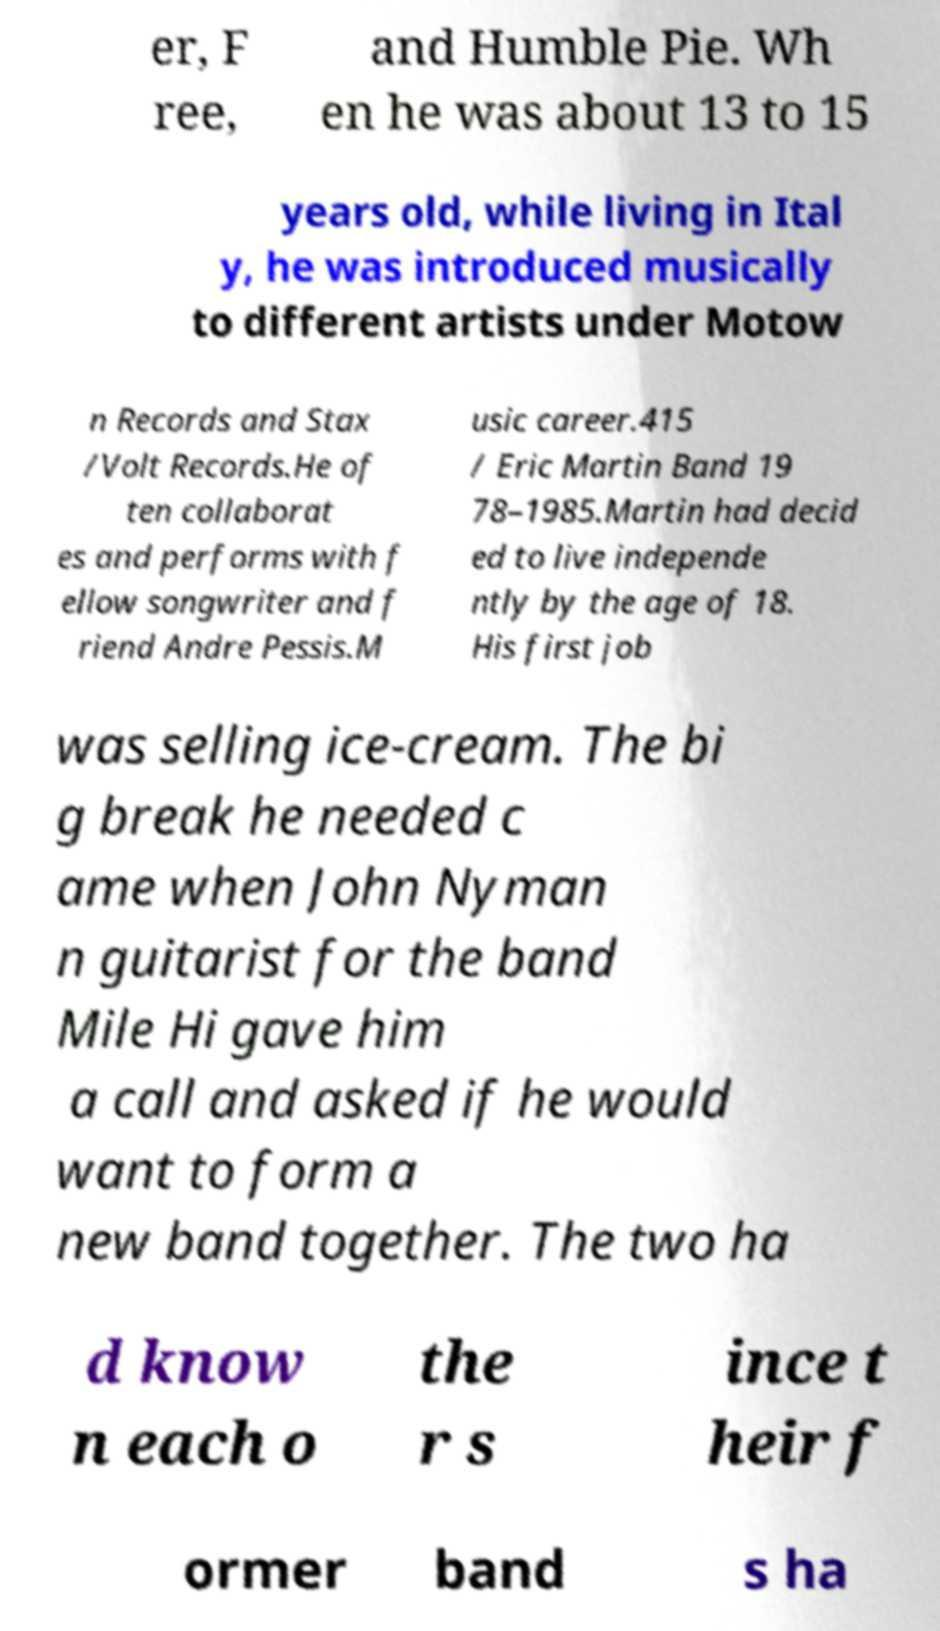Please identify and transcribe the text found in this image. er, F ree, and Humble Pie. Wh en he was about 13 to 15 years old, while living in Ital y, he was introduced musically to different artists under Motow n Records and Stax /Volt Records.He of ten collaborat es and performs with f ellow songwriter and f riend Andre Pessis.M usic career.415 / Eric Martin Band 19 78–1985.Martin had decid ed to live independe ntly by the age of 18. His first job was selling ice-cream. The bi g break he needed c ame when John Nyman n guitarist for the band Mile Hi gave him a call and asked if he would want to form a new band together. The two ha d know n each o the r s ince t heir f ormer band s ha 